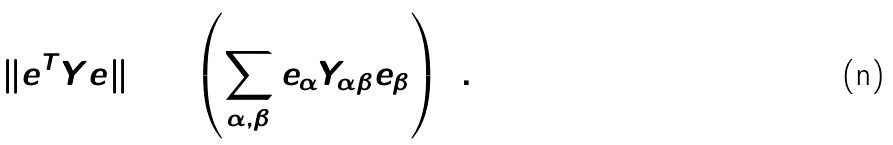Convert formula to latex. <formula><loc_0><loc_0><loc_500><loc_500>\| e ^ { T } Y e \| _ { 2 } ^ { 2 } = \left ( \sum _ { \alpha , \beta } e _ { \alpha } Y _ { \alpha \beta } e _ { \beta } \right ) ^ { 2 } .</formula> 